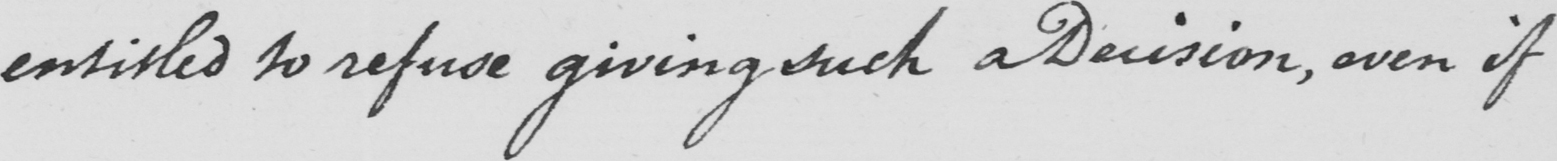Please transcribe the handwritten text in this image. entitled to refuse giving such a Decision , even if 